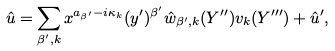Convert formula to latex. <formula><loc_0><loc_0><loc_500><loc_500>\hat { u } = \sum _ { \beta ^ { \prime } , k } x ^ { a _ { \beta ^ { \prime } } - i \kappa _ { k } } ( y ^ { \prime } ) ^ { \beta ^ { \prime } } \hat { w } _ { \beta ^ { \prime } , k } ( Y ^ { \prime \prime } ) v _ { k } ( Y ^ { \prime \prime \prime } ) + \hat { u } ^ { \prime } ,</formula> 